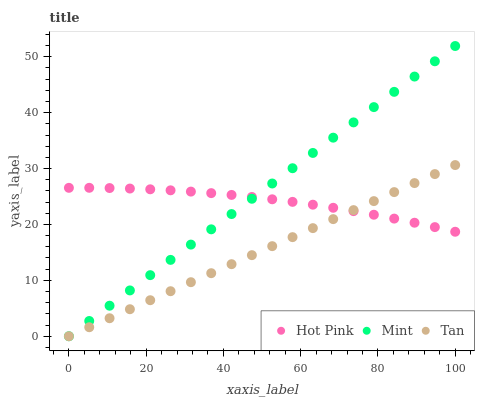Does Tan have the minimum area under the curve?
Answer yes or no. Yes. Does Mint have the maximum area under the curve?
Answer yes or no. Yes. Does Hot Pink have the minimum area under the curve?
Answer yes or no. No. Does Hot Pink have the maximum area under the curve?
Answer yes or no. No. Is Tan the smoothest?
Answer yes or no. Yes. Is Hot Pink the roughest?
Answer yes or no. Yes. Is Mint the smoothest?
Answer yes or no. No. Is Mint the roughest?
Answer yes or no. No. Does Tan have the lowest value?
Answer yes or no. Yes. Does Hot Pink have the lowest value?
Answer yes or no. No. Does Mint have the highest value?
Answer yes or no. Yes. Does Hot Pink have the highest value?
Answer yes or no. No. Does Tan intersect Hot Pink?
Answer yes or no. Yes. Is Tan less than Hot Pink?
Answer yes or no. No. Is Tan greater than Hot Pink?
Answer yes or no. No. 